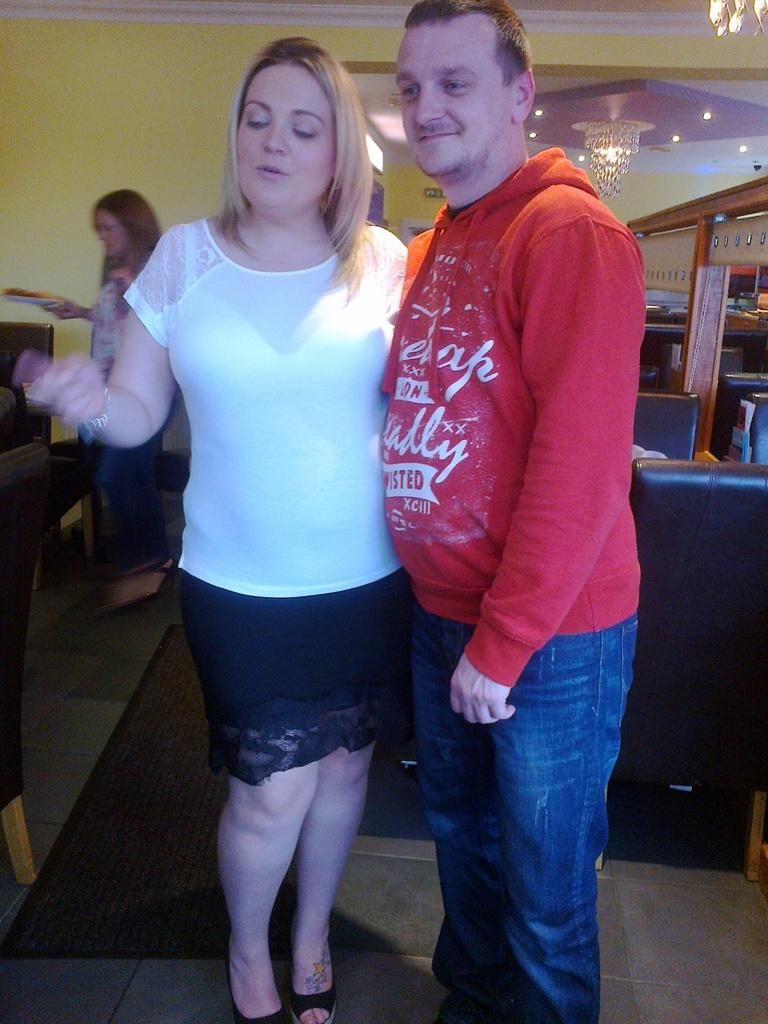How many people are present in the image? There are two people, a woman and a man, present in the image. What are the positions of the woman and man in the image? Both the woman and man are standing in the image. What can be seen in the background of the image? There are chandeliers, chairs, walls, and ceiling lights in the background of the image. Can you describe the person in the background of the image? The person in the background of the image is holding a plate. What is the most popular attraction in the image? There is no specific attraction mentioned or visible in the image. Can you see a cat in the image? There is no cat present in the image. 